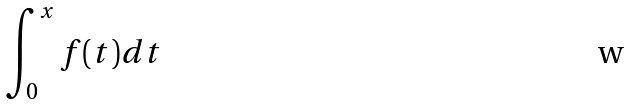<formula> <loc_0><loc_0><loc_500><loc_500>\int _ { 0 } ^ { x } f ( t ) d t</formula> 